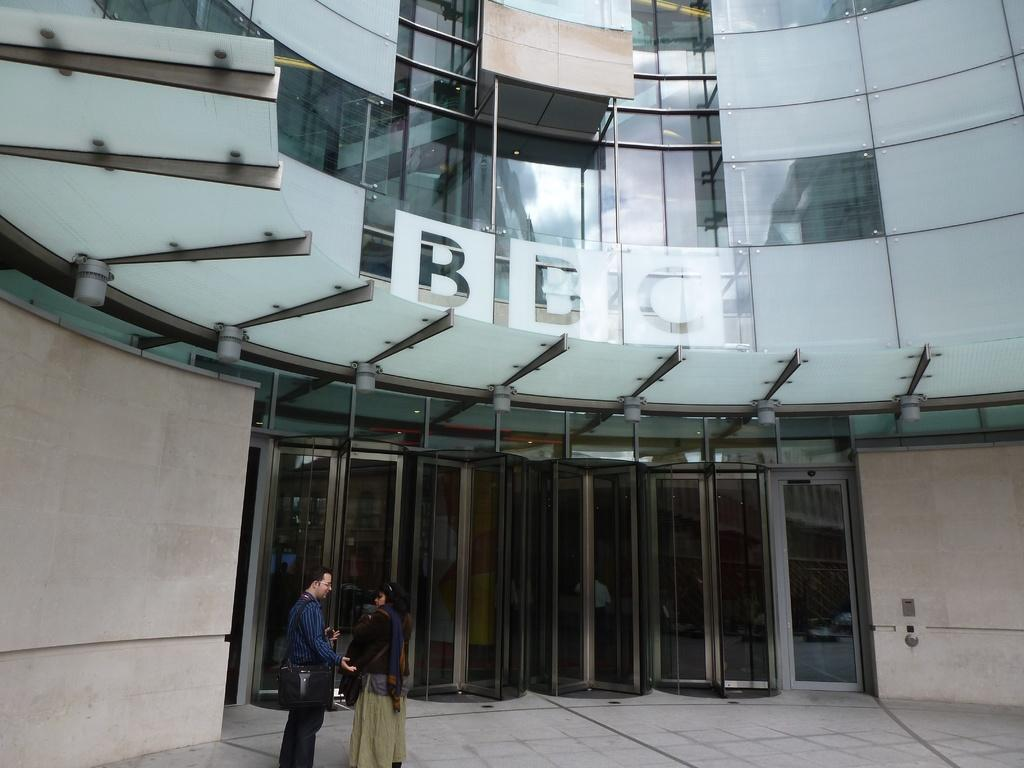What type of structure is visible in the image? There is a building in the image. What can be seen on the building? There is text written on the building. What are some features of the building? The building has glass windows and doors. How many people are present in the image? There are two people standing in the image. What type of record is being played by the people in the image? There is no record or music player visible in the image, so it cannot be determined if a record is being played. 